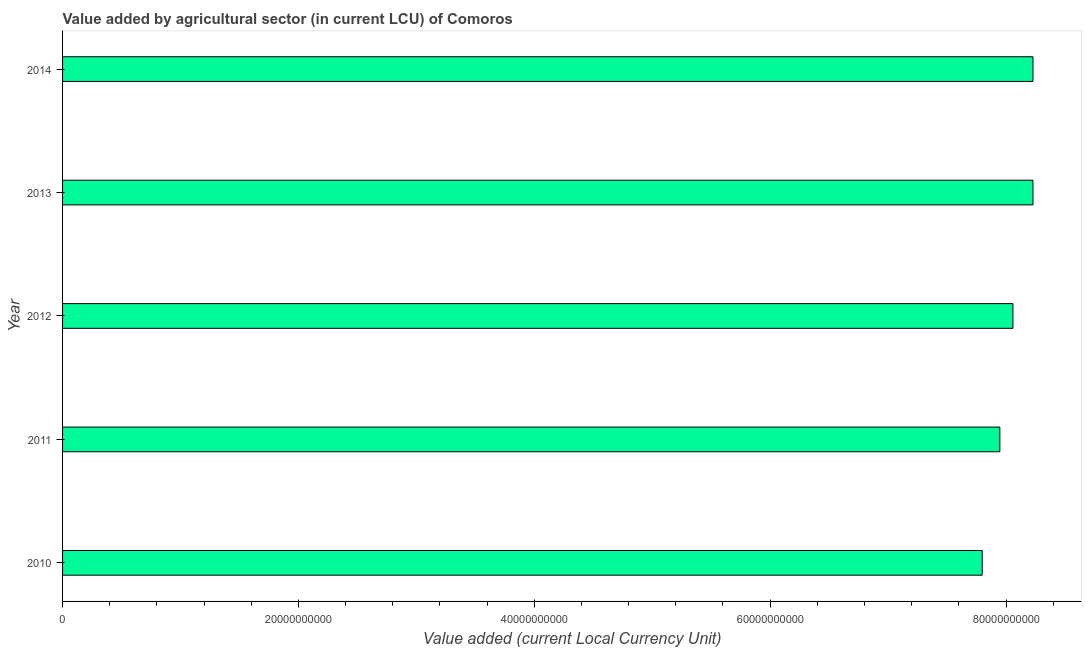Does the graph contain any zero values?
Offer a terse response. No. Does the graph contain grids?
Keep it short and to the point. No. What is the title of the graph?
Your response must be concise. Value added by agricultural sector (in current LCU) of Comoros. What is the label or title of the X-axis?
Your answer should be very brief. Value added (current Local Currency Unit). What is the value added by agriculture sector in 2013?
Offer a terse response. 8.23e+1. Across all years, what is the maximum value added by agriculture sector?
Your answer should be compact. 8.23e+1. Across all years, what is the minimum value added by agriculture sector?
Your answer should be very brief. 7.80e+1. In which year was the value added by agriculture sector maximum?
Provide a succinct answer. 2013. What is the sum of the value added by agriculture sector?
Your response must be concise. 4.03e+11. What is the difference between the value added by agriculture sector in 2010 and 2012?
Provide a succinct answer. -2.60e+09. What is the average value added by agriculture sector per year?
Keep it short and to the point. 8.05e+1. What is the median value added by agriculture sector?
Offer a very short reply. 8.06e+1. In how many years, is the value added by agriculture sector greater than 12000000000 LCU?
Offer a very short reply. 5. Do a majority of the years between 2011 and 2012 (inclusive) have value added by agriculture sector greater than 4000000000 LCU?
Your answer should be very brief. Yes. What is the ratio of the value added by agriculture sector in 2011 to that in 2013?
Provide a succinct answer. 0.97. Is the value added by agriculture sector in 2010 less than that in 2014?
Your answer should be very brief. Yes. What is the difference between the highest and the second highest value added by agriculture sector?
Provide a short and direct response. 0. Is the sum of the value added by agriculture sector in 2012 and 2014 greater than the maximum value added by agriculture sector across all years?
Ensure brevity in your answer.  Yes. What is the difference between the highest and the lowest value added by agriculture sector?
Your answer should be compact. 4.30e+09. In how many years, is the value added by agriculture sector greater than the average value added by agriculture sector taken over all years?
Provide a succinct answer. 3. How many bars are there?
Provide a short and direct response. 5. Are all the bars in the graph horizontal?
Your answer should be very brief. Yes. What is the Value added (current Local Currency Unit) in 2010?
Provide a short and direct response. 7.80e+1. What is the Value added (current Local Currency Unit) in 2011?
Make the answer very short. 7.95e+1. What is the Value added (current Local Currency Unit) of 2012?
Keep it short and to the point. 8.06e+1. What is the Value added (current Local Currency Unit) of 2013?
Ensure brevity in your answer.  8.23e+1. What is the Value added (current Local Currency Unit) in 2014?
Your response must be concise. 8.23e+1. What is the difference between the Value added (current Local Currency Unit) in 2010 and 2011?
Provide a short and direct response. -1.49e+09. What is the difference between the Value added (current Local Currency Unit) in 2010 and 2012?
Provide a succinct answer. -2.60e+09. What is the difference between the Value added (current Local Currency Unit) in 2010 and 2013?
Your answer should be compact. -4.30e+09. What is the difference between the Value added (current Local Currency Unit) in 2010 and 2014?
Offer a terse response. -4.30e+09. What is the difference between the Value added (current Local Currency Unit) in 2011 and 2012?
Your response must be concise. -1.11e+09. What is the difference between the Value added (current Local Currency Unit) in 2011 and 2013?
Keep it short and to the point. -2.81e+09. What is the difference between the Value added (current Local Currency Unit) in 2011 and 2014?
Provide a short and direct response. -2.81e+09. What is the difference between the Value added (current Local Currency Unit) in 2012 and 2013?
Keep it short and to the point. -1.70e+09. What is the difference between the Value added (current Local Currency Unit) in 2012 and 2014?
Provide a succinct answer. -1.70e+09. What is the ratio of the Value added (current Local Currency Unit) in 2010 to that in 2012?
Your answer should be compact. 0.97. What is the ratio of the Value added (current Local Currency Unit) in 2010 to that in 2013?
Give a very brief answer. 0.95. What is the ratio of the Value added (current Local Currency Unit) in 2010 to that in 2014?
Your answer should be very brief. 0.95. What is the ratio of the Value added (current Local Currency Unit) in 2011 to that in 2013?
Give a very brief answer. 0.97. What is the ratio of the Value added (current Local Currency Unit) in 2011 to that in 2014?
Give a very brief answer. 0.97. 